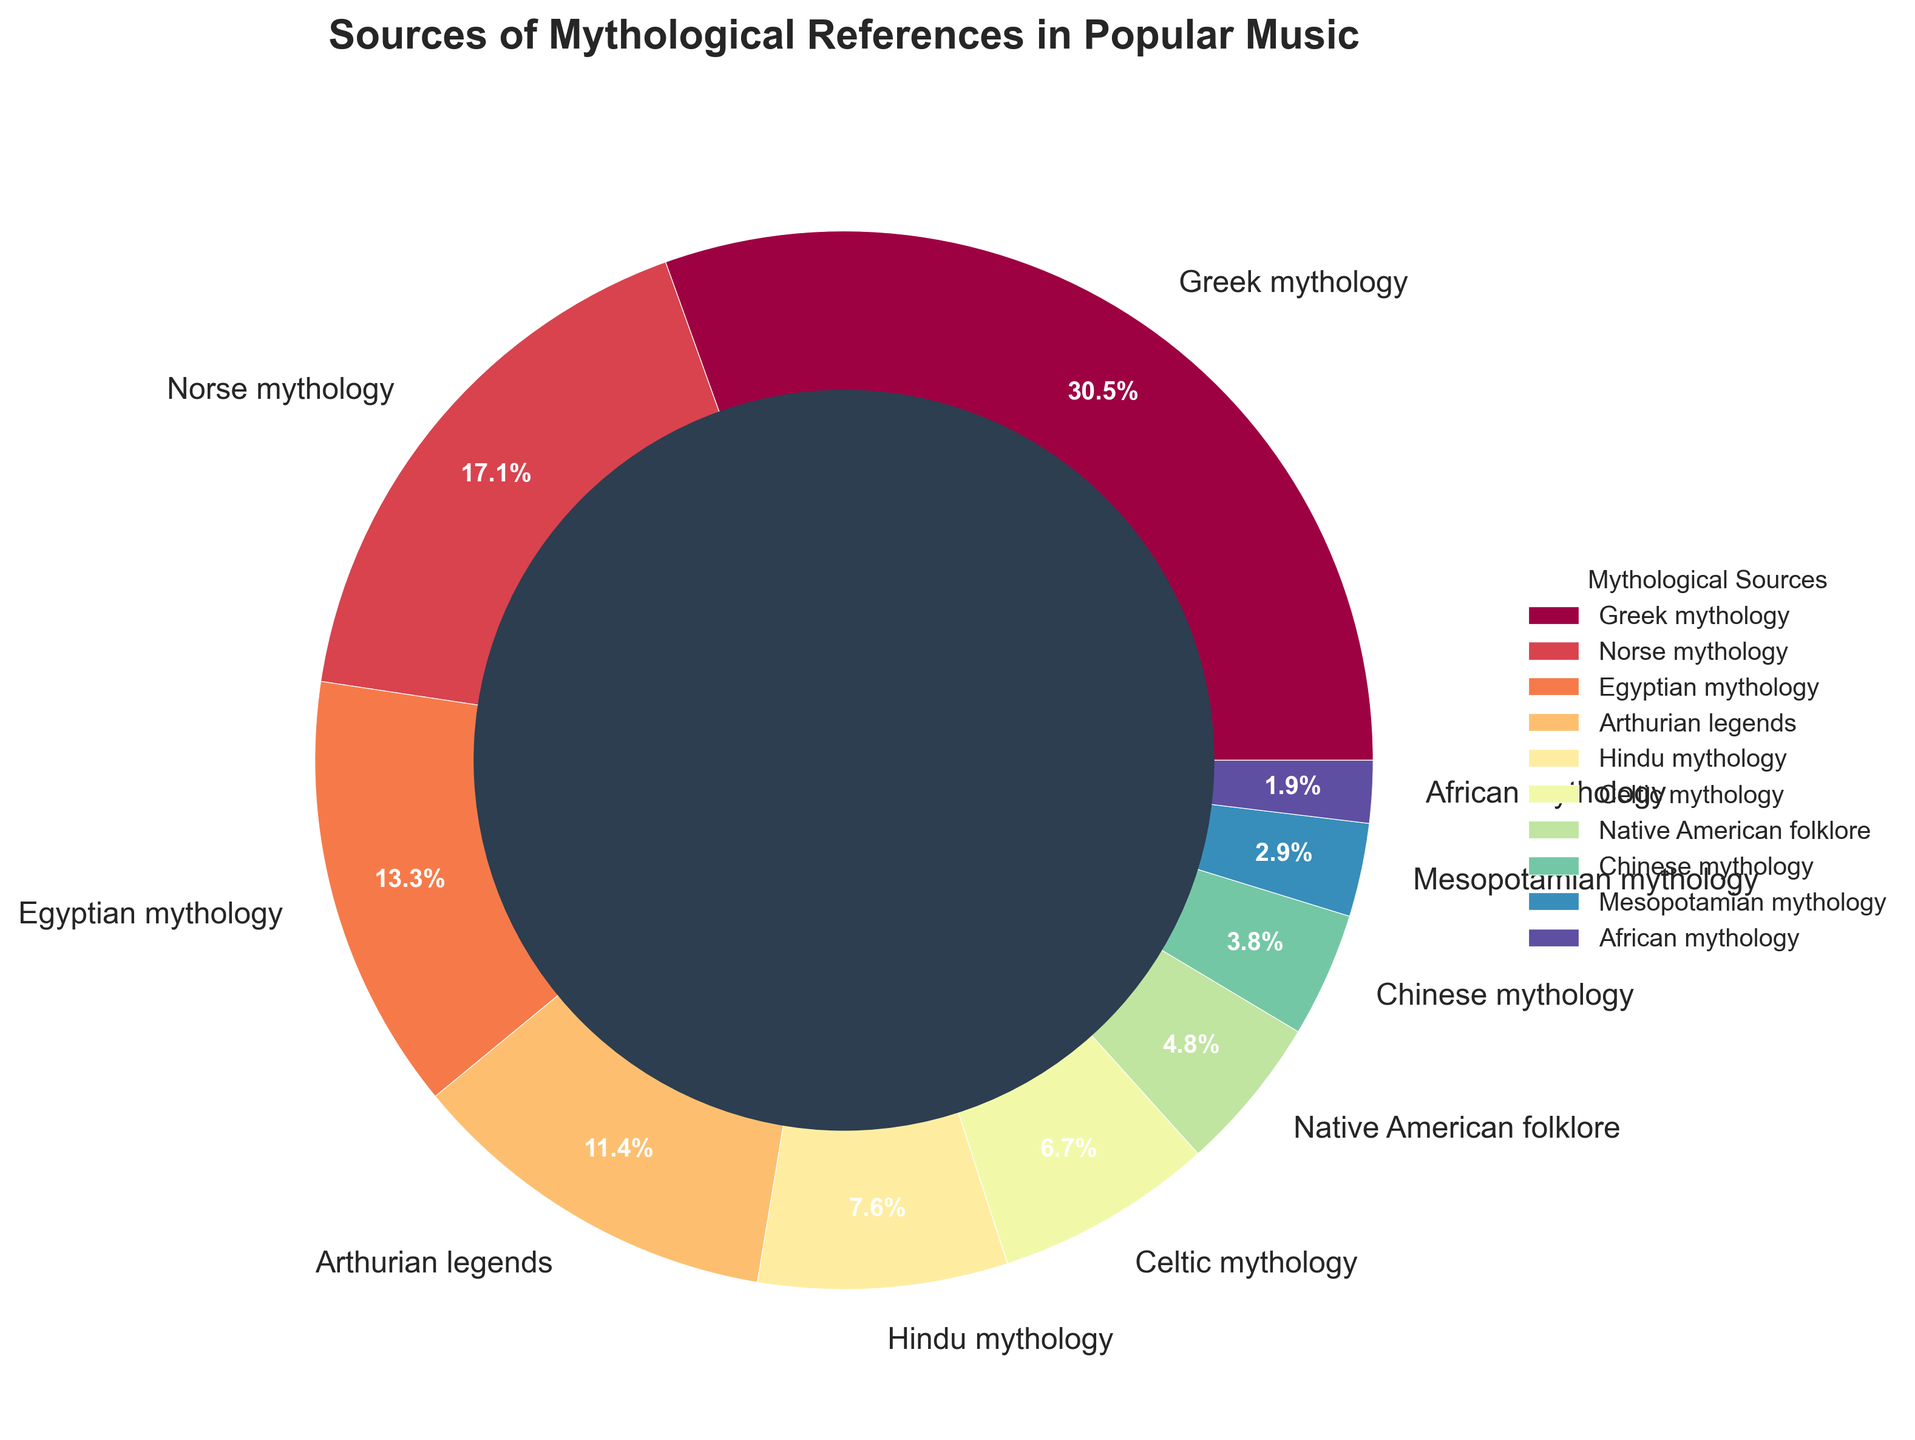What is the largest source of mythological references in popular music? Greek mythology has the highest percentage in the pie chart. This can be directly observed by looking at the label and the size of the corresponding section.
Answer: Greek mythology How much greater is the percentage of Greek mythology compared to Norse mythology? Greek mythology accounts for 32% while Norse mythology accounts for 18%. To find the difference, subtract 18 from 32. So, 32 - 18 = 14.
Answer: 14% Which mythology is represented in a greenish hue in the pie chart? The greenish hue corresponds to Norse mythology. This can be observed from the color mapping in the legend corresponding to the pie section.
Answer: Norse mythology What's the combined percentage of Egyptian mythology and Arthurian legends? The percentage of Egyptian mythology is 14% and that of Arthurian legends is 12%. To find the combined percentage, add 14 and 12. So, 14 + 12 = 26.
Answer: 26% Is Hindu mythology more or less referenced than Celtic mythology in popular music? Hindu mythology has an 8% representation while Celtic mythology has 7%. Therefore, Hindu mythology is more referenced than Celtic mythology.
Answer: More How do the representations of Native American folklore and Chinese mythology compare? Native American folklore accounts for 5% while Chinese mythology accounts for 4%. Therefore, Native American folklore is represented more than Chinese mythology by 1%.
Answer: Native American folklore has more references What's the total percentage of mythological references attributed to both Mesopotamian and African mythology? Mesopotamian mythology contributes 3% and African mythology contributes 2%. To find the total, add 3 and 2. So, 3 + 2 = 5.
Answer: 5% Which mythology has the smallest representation in popular music? African mythology has the smallest representation at 2%. This can be identified by looking at the smallest section of the pie chart with its label.
Answer: African mythology Among the mythologies with percentages higher than 10%, how many are there, and which ones are they? There are three mythologies with percentages higher than 10%: Greek mythology (32%), Norse mythology (18%), and Egyptian mythology (14%). This can be observed by looking at the labels on the pie chart.
Answer: 3; Greek, Norse, Egyptian Combine the percentages of the two least mentioned mythologies and then compare it with the percentage of Arthurian legends. Which is greater and by how much? The least mentioned mythologies are African mythology (2%) and Mesopotamian mythology (3%). Their combined percentage is 2 + 3 = 5%. Arthurian legends have 12%. Subtract 5 from 12 to find the difference. So, 12 - 5 = 7.
Answer: Arthurian legends by 7% 